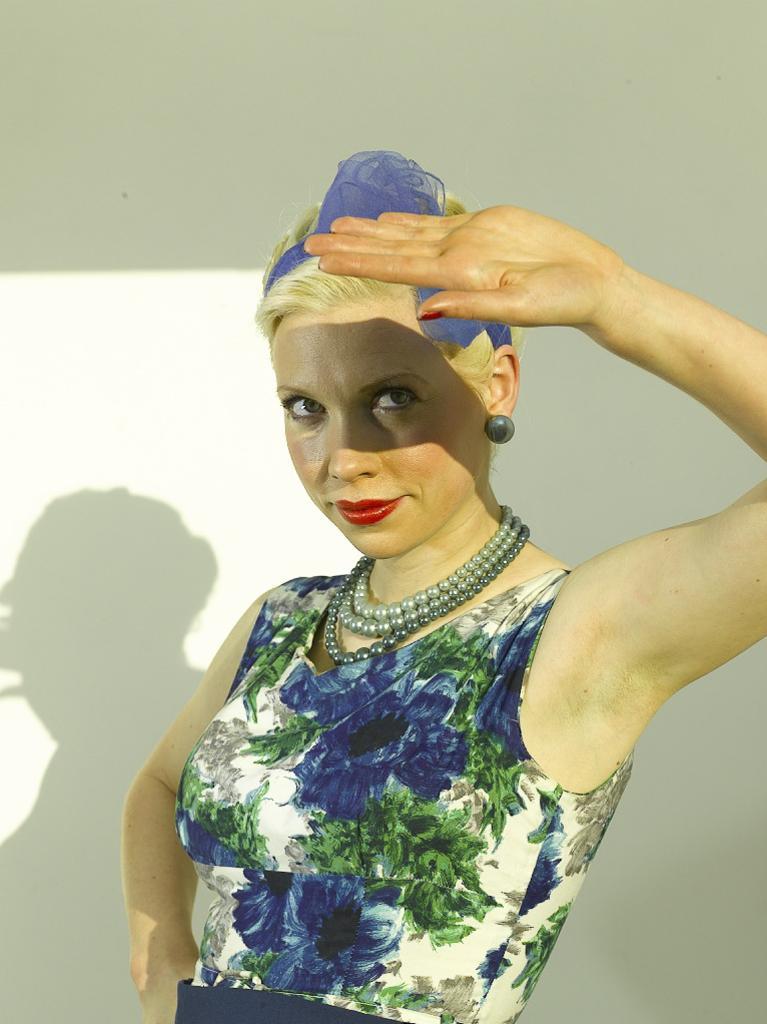Describe this image in one or two sentences. In this picture we can see a woman. We can see the shadow of a woman on the wall visible in the background. 